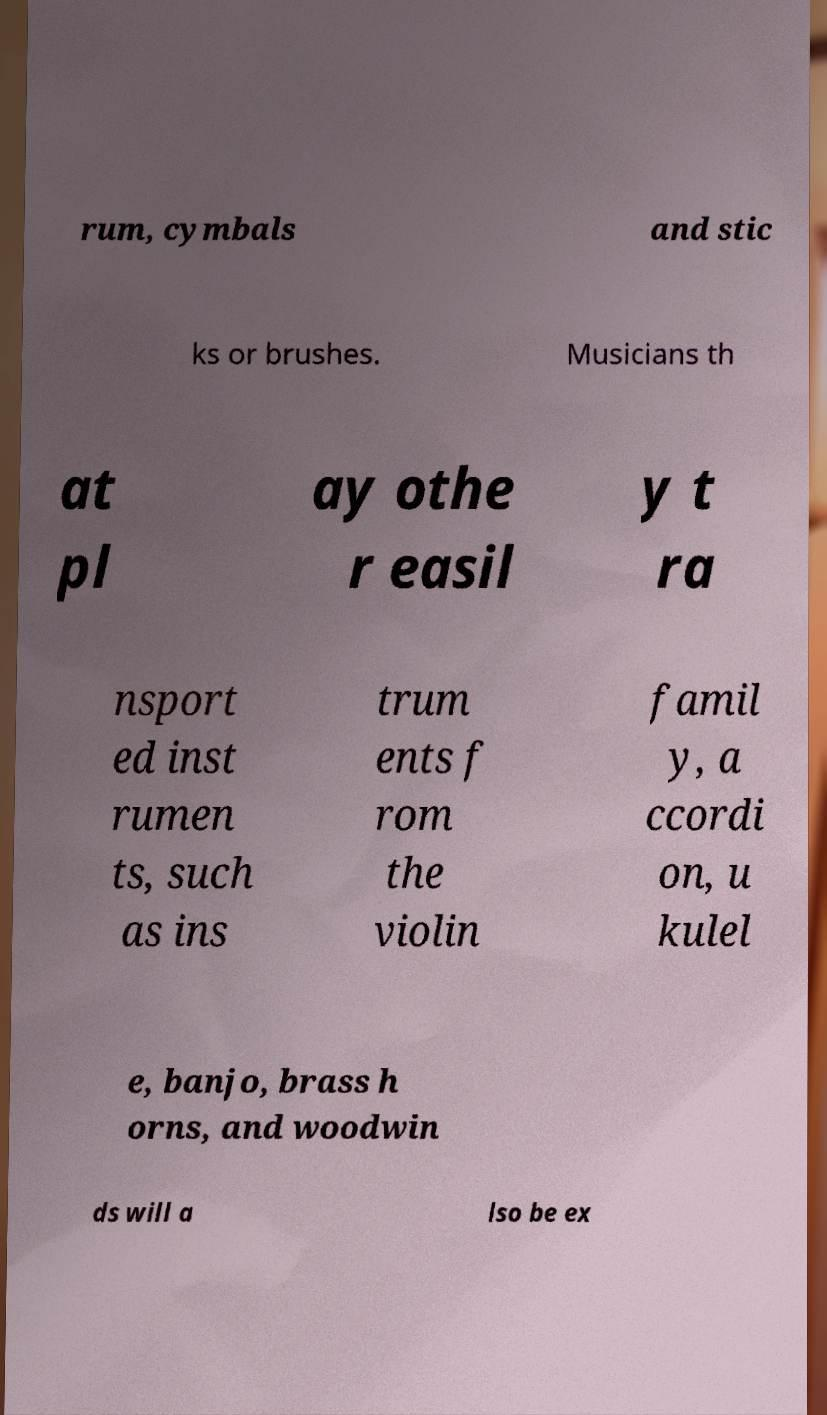For documentation purposes, I need the text within this image transcribed. Could you provide that? rum, cymbals and stic ks or brushes. Musicians th at pl ay othe r easil y t ra nsport ed inst rumen ts, such as ins trum ents f rom the violin famil y, a ccordi on, u kulel e, banjo, brass h orns, and woodwin ds will a lso be ex 